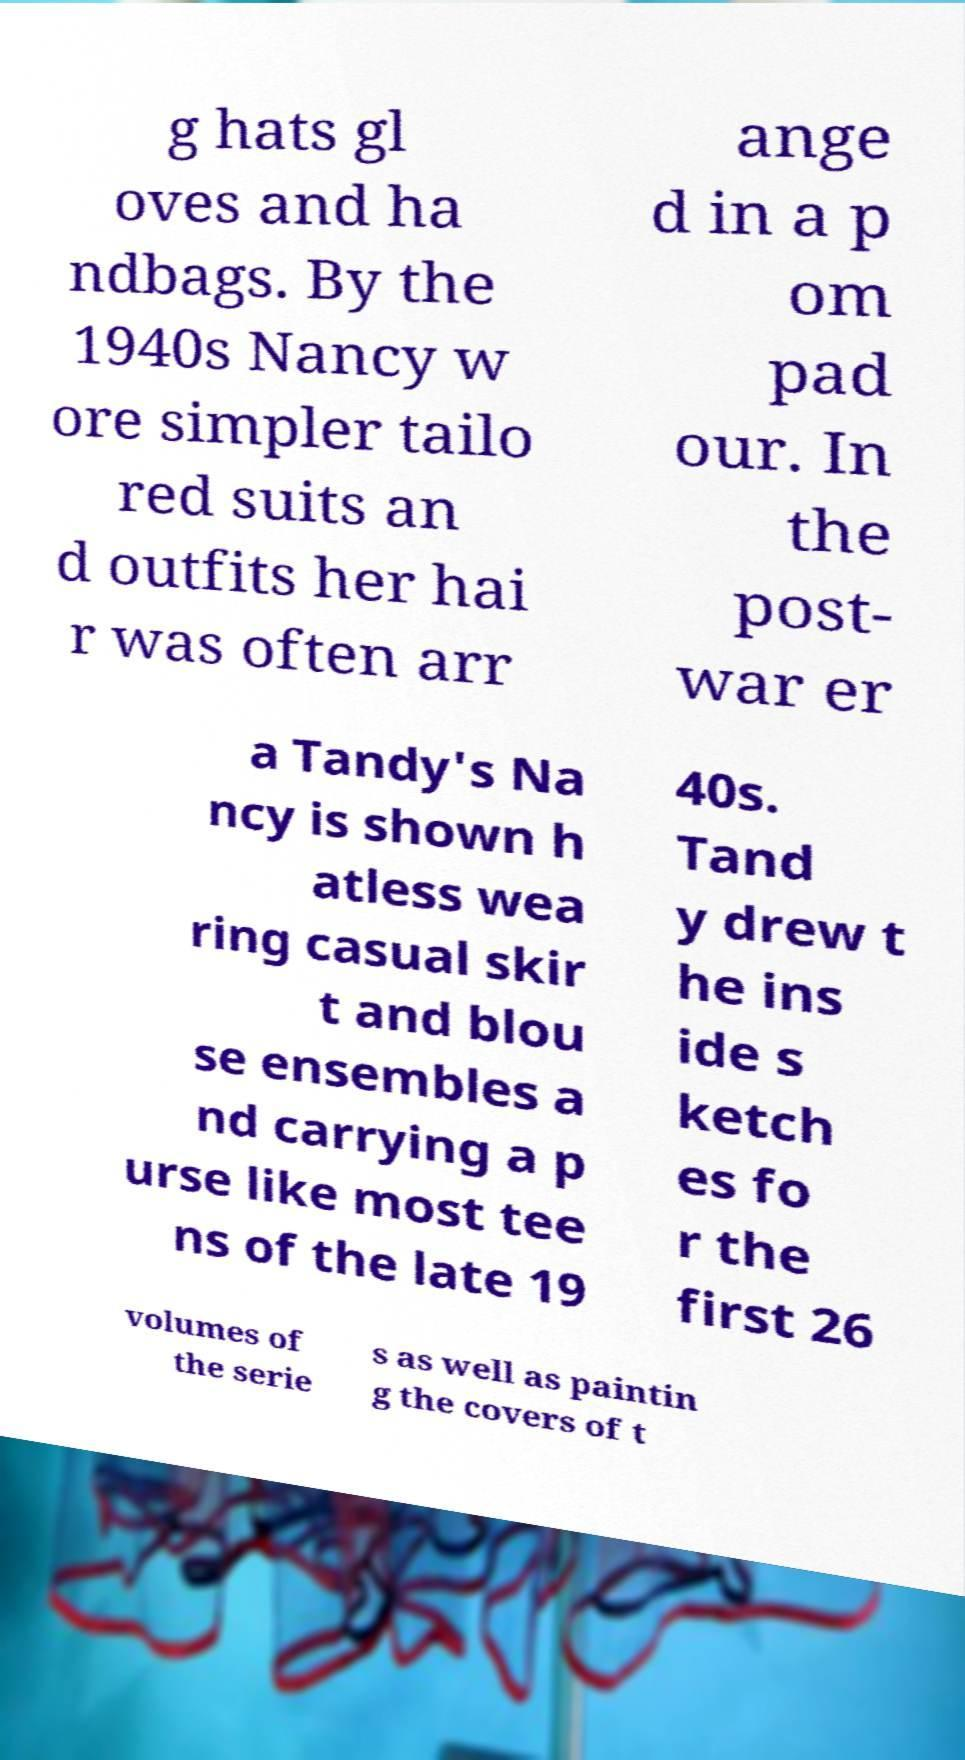Please read and relay the text visible in this image. What does it say? g hats gl oves and ha ndbags. By the 1940s Nancy w ore simpler tailo red suits an d outfits her hai r was often arr ange d in a p om pad our. In the post- war er a Tandy's Na ncy is shown h atless wea ring casual skir t and blou se ensembles a nd carrying a p urse like most tee ns of the late 19 40s. Tand y drew t he ins ide s ketch es fo r the first 26 volumes of the serie s as well as paintin g the covers of t 